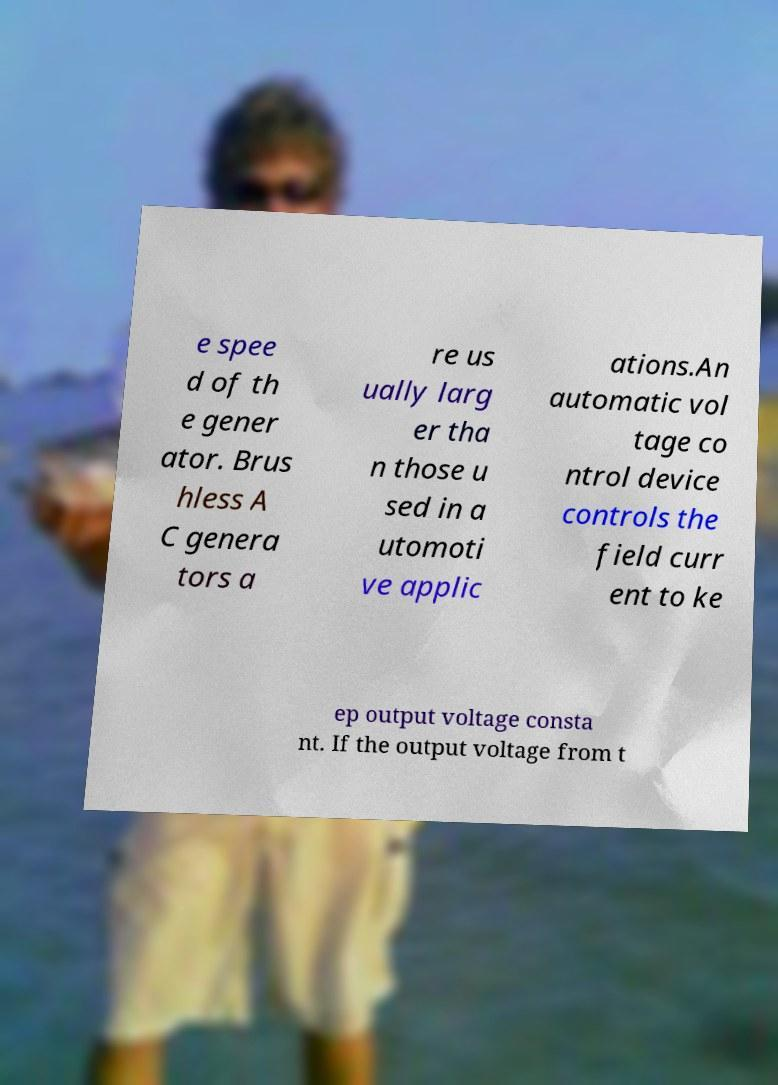For documentation purposes, I need the text within this image transcribed. Could you provide that? e spee d of th e gener ator. Brus hless A C genera tors a re us ually larg er tha n those u sed in a utomoti ve applic ations.An automatic vol tage co ntrol device controls the field curr ent to ke ep output voltage consta nt. If the output voltage from t 